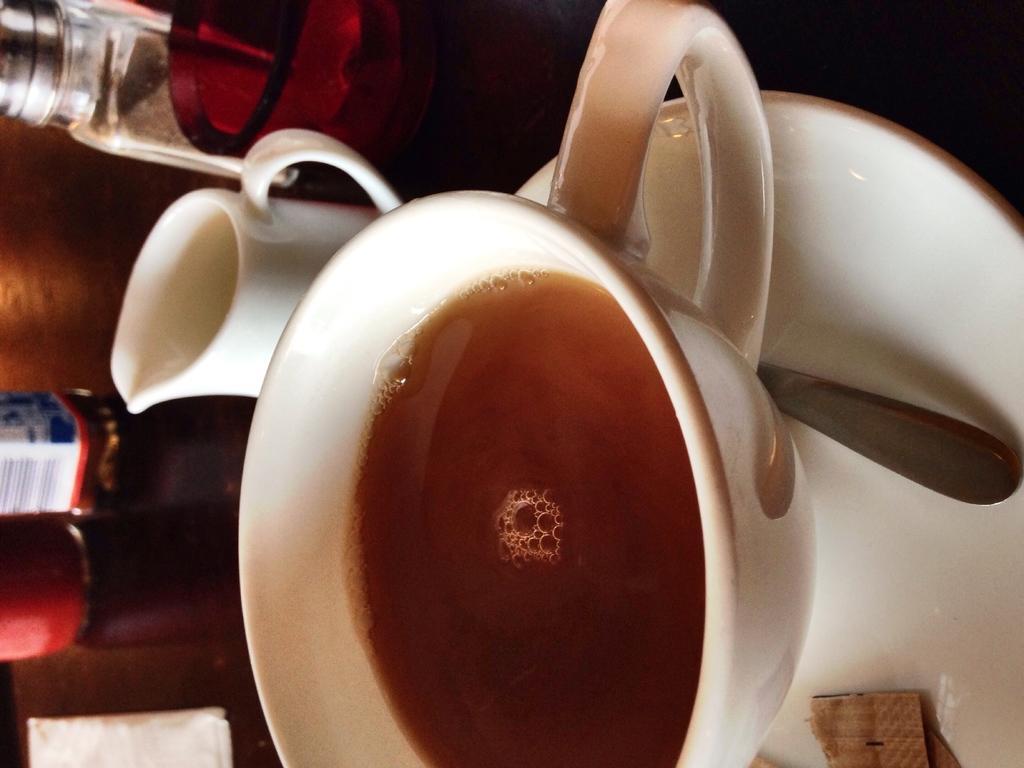In one or two sentences, can you explain what this image depicts? In this picture we can see few cups, saucer, spoon, bottles and other things on the table, and also we can see drink in the cup. 